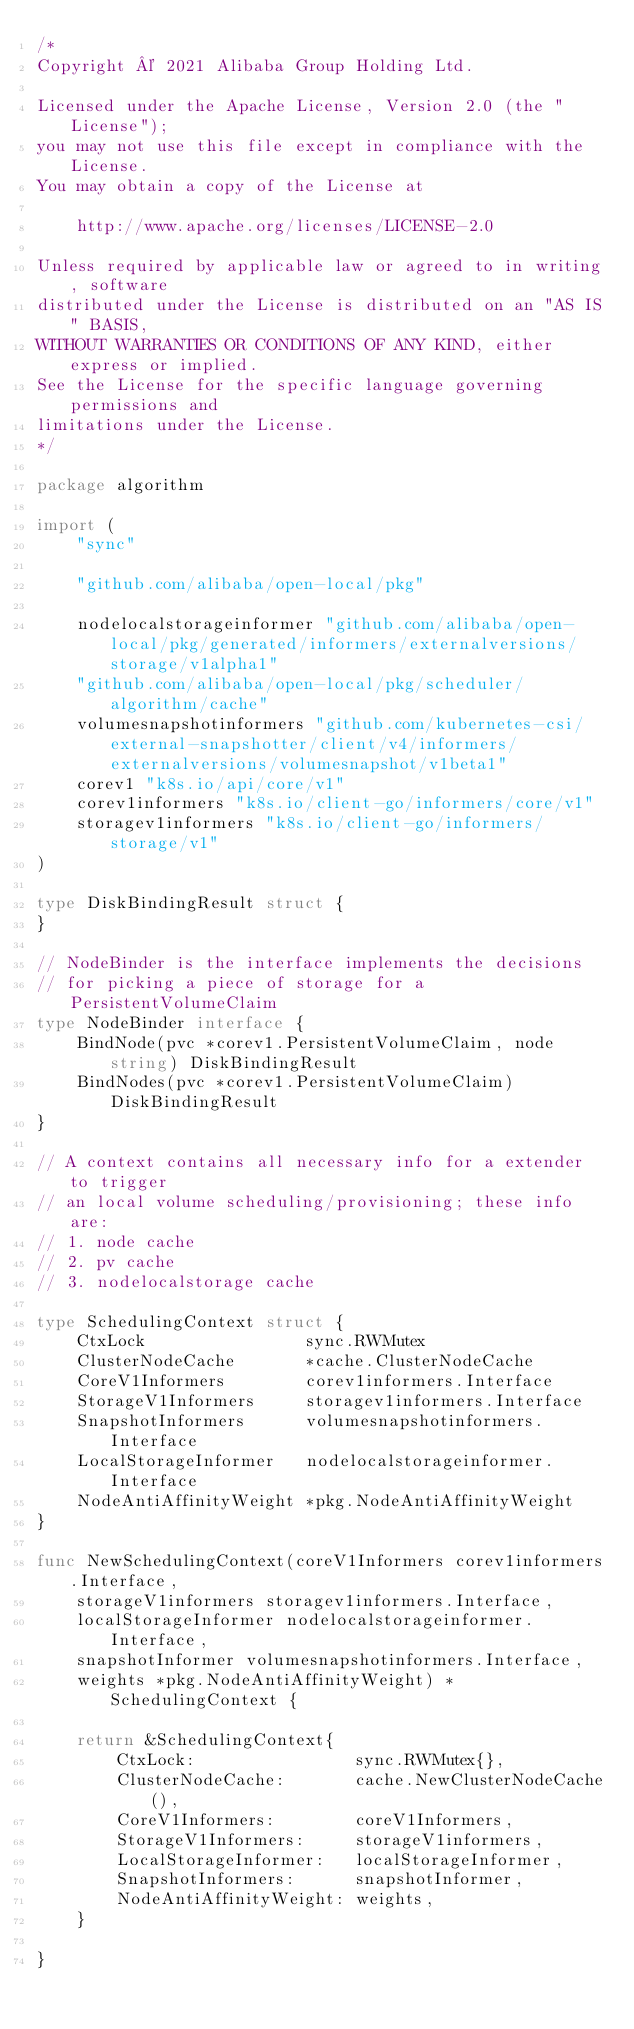Convert code to text. <code><loc_0><loc_0><loc_500><loc_500><_Go_>/*
Copyright © 2021 Alibaba Group Holding Ltd.

Licensed under the Apache License, Version 2.0 (the "License");
you may not use this file except in compliance with the License.
You may obtain a copy of the License at

    http://www.apache.org/licenses/LICENSE-2.0

Unless required by applicable law or agreed to in writing, software
distributed under the License is distributed on an "AS IS" BASIS,
WITHOUT WARRANTIES OR CONDITIONS OF ANY KIND, either express or implied.
See the License for the specific language governing permissions and
limitations under the License.
*/

package algorithm

import (
	"sync"

	"github.com/alibaba/open-local/pkg"

	nodelocalstorageinformer "github.com/alibaba/open-local/pkg/generated/informers/externalversions/storage/v1alpha1"
	"github.com/alibaba/open-local/pkg/scheduler/algorithm/cache"
	volumesnapshotinformers "github.com/kubernetes-csi/external-snapshotter/client/v4/informers/externalversions/volumesnapshot/v1beta1"
	corev1 "k8s.io/api/core/v1"
	corev1informers "k8s.io/client-go/informers/core/v1"
	storagev1informers "k8s.io/client-go/informers/storage/v1"
)

type DiskBindingResult struct {
}

// NodeBinder is the interface implements the decisions
// for picking a piece of storage for a PersistentVolumeClaim
type NodeBinder interface {
	BindNode(pvc *corev1.PersistentVolumeClaim, node string) DiskBindingResult
	BindNodes(pvc *corev1.PersistentVolumeClaim) DiskBindingResult
}

// A context contains all necessary info for a extender to trigger
// an local volume scheduling/provisioning; these info are:
// 1. node cache
// 2. pv cache
// 3. nodelocalstorage cache

type SchedulingContext struct {
	CtxLock                sync.RWMutex
	ClusterNodeCache       *cache.ClusterNodeCache
	CoreV1Informers        corev1informers.Interface
	StorageV1Informers     storagev1informers.Interface
	SnapshotInformers      volumesnapshotinformers.Interface
	LocalStorageInformer   nodelocalstorageinformer.Interface
	NodeAntiAffinityWeight *pkg.NodeAntiAffinityWeight
}

func NewSchedulingContext(coreV1Informers corev1informers.Interface,
	storageV1informers storagev1informers.Interface,
	localStorageInformer nodelocalstorageinformer.Interface,
	snapshotInformer volumesnapshotinformers.Interface,
	weights *pkg.NodeAntiAffinityWeight) *SchedulingContext {

	return &SchedulingContext{
		CtxLock:                sync.RWMutex{},
		ClusterNodeCache:       cache.NewClusterNodeCache(),
		CoreV1Informers:        coreV1Informers,
		StorageV1Informers:     storageV1informers,
		LocalStorageInformer:   localStorageInformer,
		SnapshotInformers:      snapshotInformer,
		NodeAntiAffinityWeight: weights,
	}

}
</code> 